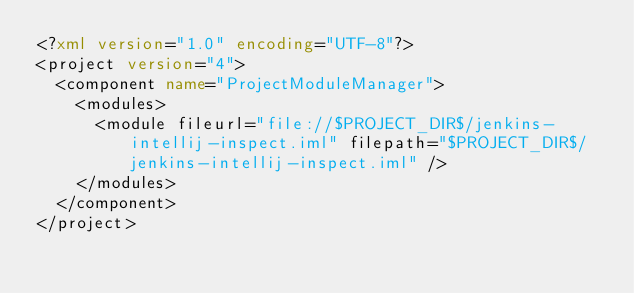Convert code to text. <code><loc_0><loc_0><loc_500><loc_500><_XML_><?xml version="1.0" encoding="UTF-8"?>
<project version="4">
  <component name="ProjectModuleManager">
    <modules>
      <module fileurl="file://$PROJECT_DIR$/jenkins-intellij-inspect.iml" filepath="$PROJECT_DIR$/jenkins-intellij-inspect.iml" />
    </modules>
  </component>
</project></code> 